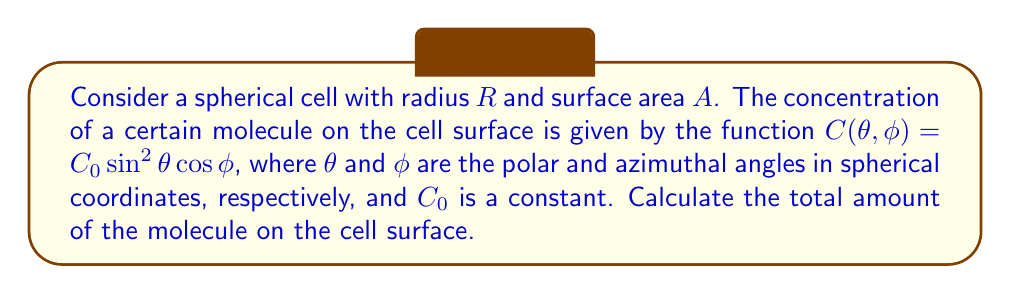Teach me how to tackle this problem. To solve this problem, we'll follow these steps:

1) The surface area element of a sphere in spherical coordinates is given by:
   $$dA = R^2 \sin\theta d\theta d\phi$$

2) The total amount of the molecule is the integral of the concentration over the entire surface:
   $$\text{Total Amount} = \int_A C(\theta, \phi) dA$$

3) Substituting the given concentration function and surface area element:
   $$\text{Total Amount} = \int_0^{2\pi} \int_0^{\pi} C_0 \sin^2\theta \cos\phi \cdot R^2 \sin\theta d\theta d\phi$$

4) Simplifying:
   $$\text{Total Amount} = C_0R^2 \int_0^{2\pi} \cos\phi d\phi \int_0^{\pi} \sin^3\theta d\theta$$

5) Solving the $\phi$ integral:
   $$\int_0^{2\pi} \cos\phi d\phi = [\sin\phi]_0^{2\pi} = 0$$

6) Since the $\phi$ integral evaluates to zero, the total amount is zero regardless of the $\theta$ integral.

This result shows that the positive and negative contributions of the molecule's concentration over the sphere's surface cancel out completely due to the $\cos\phi$ term in the concentration function.
Answer: 0 